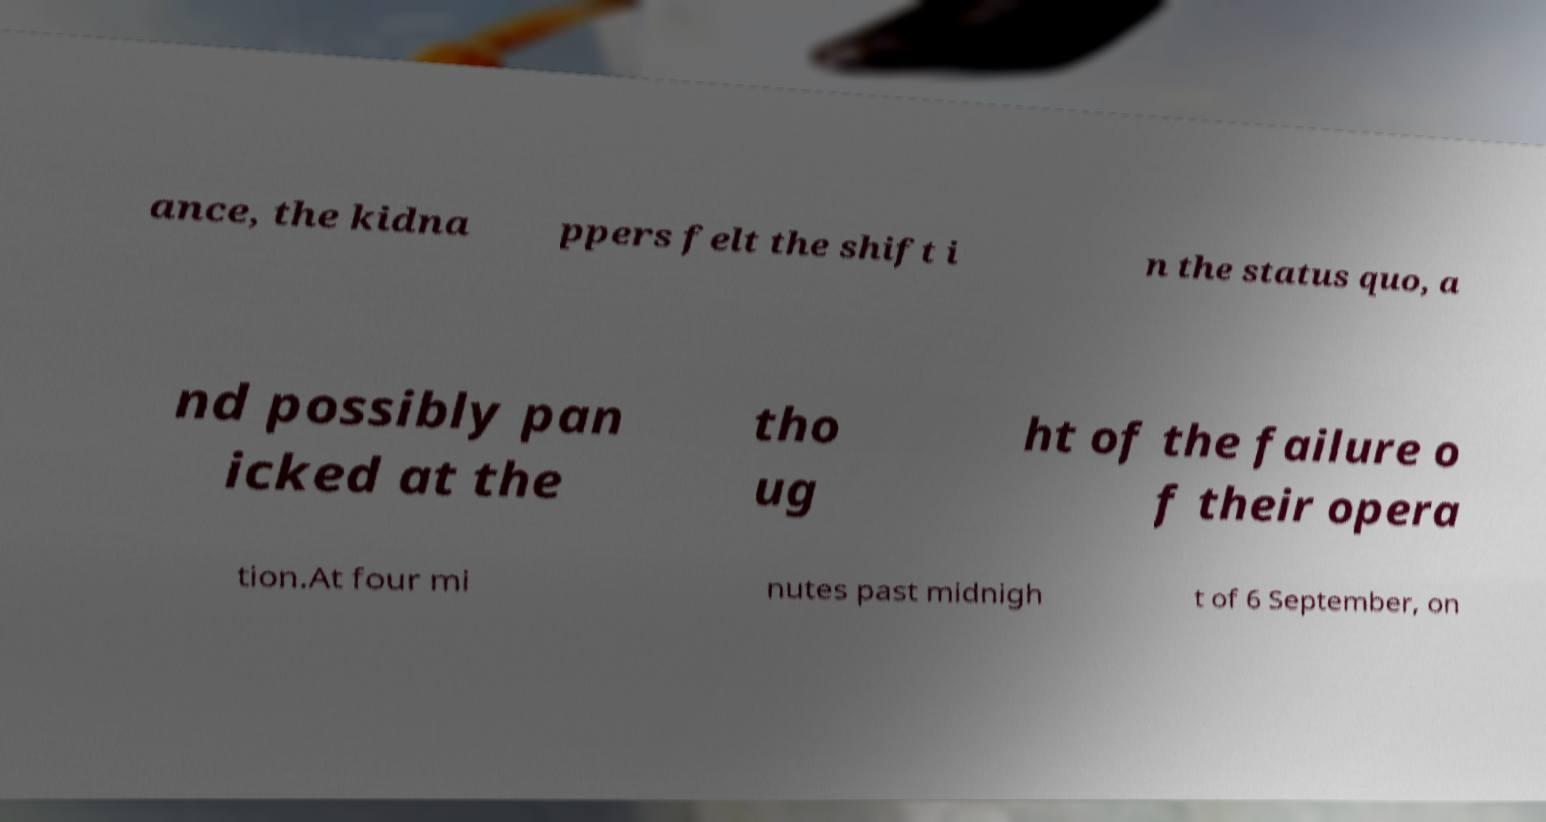I need the written content from this picture converted into text. Can you do that? ance, the kidna ppers felt the shift i n the status quo, a nd possibly pan icked at the tho ug ht of the failure o f their opera tion.At four mi nutes past midnigh t of 6 September, on 